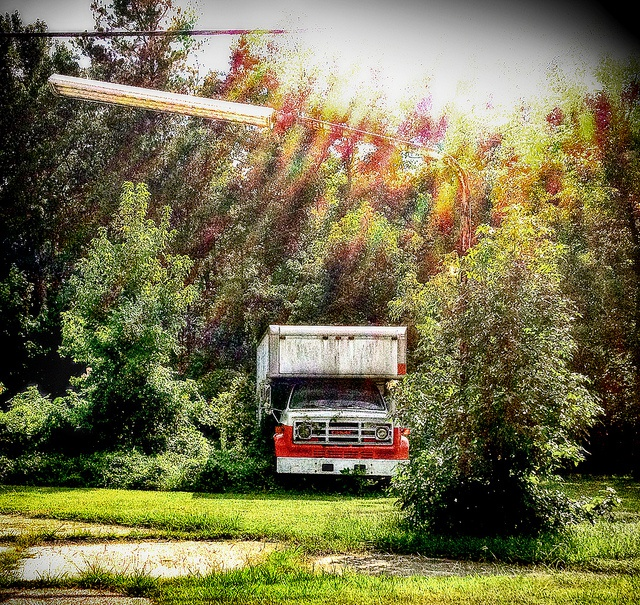Describe the objects in this image and their specific colors. I can see a truck in gray, black, lightgray, and darkgray tones in this image. 